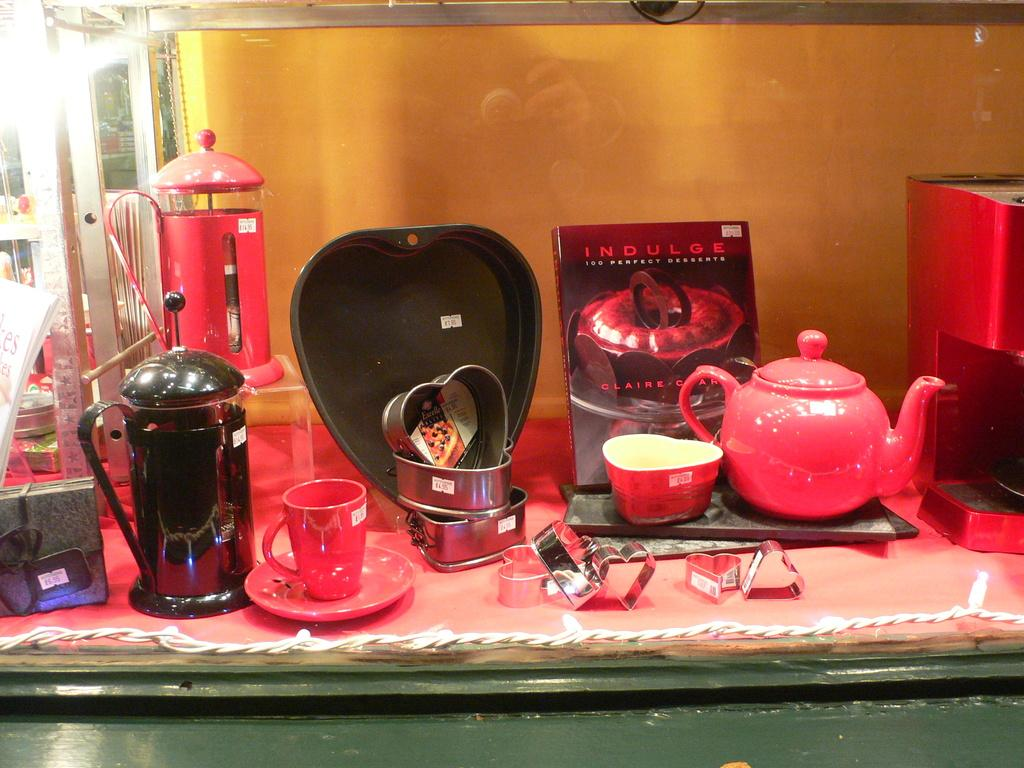Provide a one-sentence caption for the provided image. a book on a table that says indulge on it. 